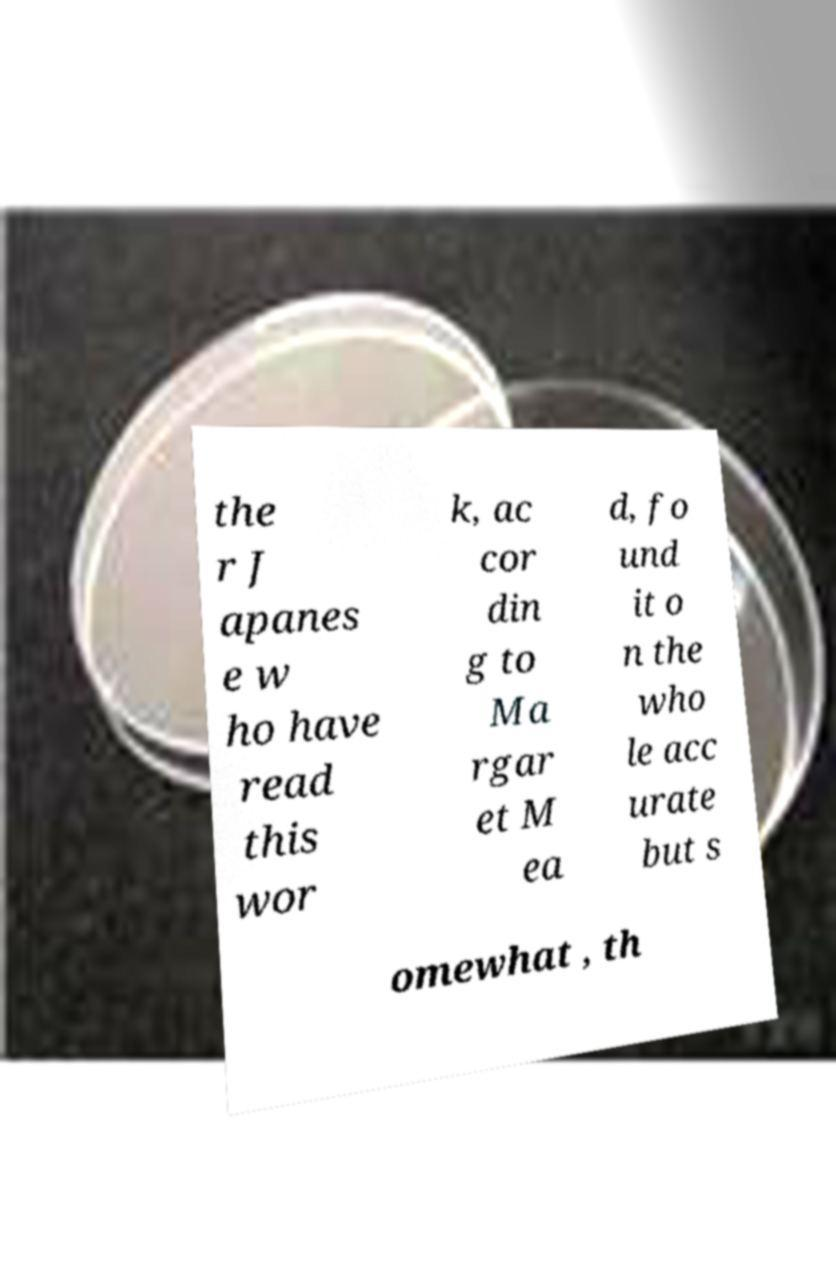Please read and relay the text visible in this image. What does it say? the r J apanes e w ho have read this wor k, ac cor din g to Ma rgar et M ea d, fo und it o n the who le acc urate but s omewhat , th 